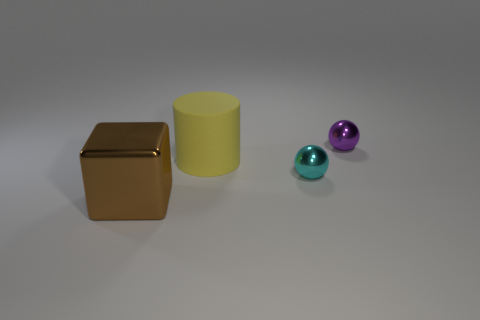Subtract all cubes. How many objects are left? 3 Add 1 big yellow rubber things. How many objects exist? 5 Subtract all cyan spheres. How many spheres are left? 1 Add 3 large brown cubes. How many large brown cubes exist? 4 Subtract 1 yellow cylinders. How many objects are left? 3 Subtract 1 cylinders. How many cylinders are left? 0 Subtract all red balls. Subtract all cyan cylinders. How many balls are left? 2 Subtract all cyan balls. How many red cylinders are left? 0 Subtract all cyan metal spheres. Subtract all large yellow cylinders. How many objects are left? 2 Add 3 brown cubes. How many brown cubes are left? 4 